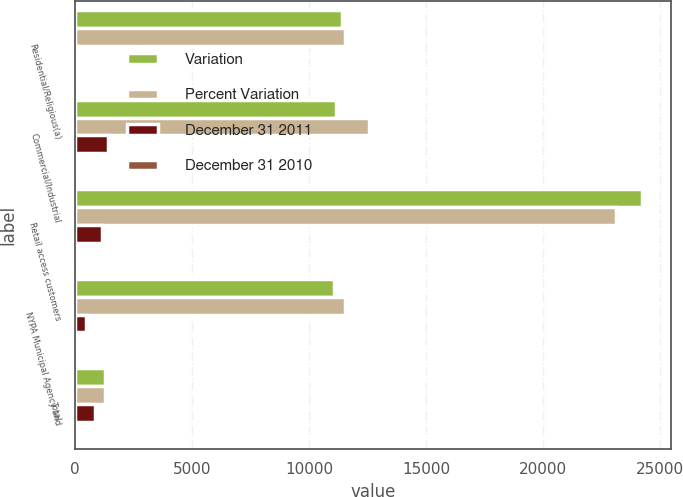Convert chart. <chart><loc_0><loc_0><loc_500><loc_500><stacked_bar_chart><ecel><fcel>Residential/Religious(a)<fcel>Commercial/Industrial<fcel>Retail access customers<fcel>NYPA Municipal Agency and<fcel>Total<nl><fcel>Variation<fcel>11404<fcel>11148<fcel>24234<fcel>11040<fcel>1273.5<nl><fcel>Percent Variation<fcel>11518<fcel>12559<fcel>23098<fcel>11518<fcel>1273.5<nl><fcel>December 31 2011<fcel>114<fcel>1411<fcel>1136<fcel>478<fcel>867<nl><fcel>December 31 2010<fcel>1<fcel>11.2<fcel>4.9<fcel>4.2<fcel>1.5<nl></chart> 